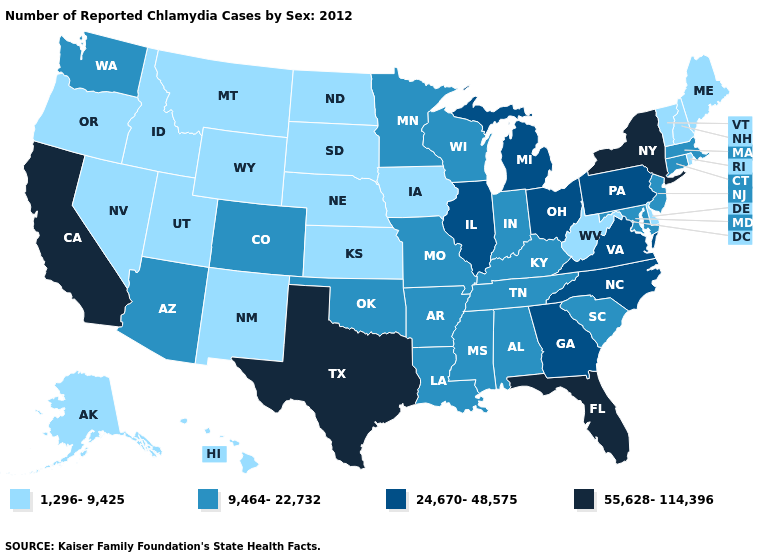Does South Dakota have the lowest value in the USA?
Keep it brief. Yes. Among the states that border Indiana , does Illinois have the highest value?
Concise answer only. Yes. Name the states that have a value in the range 1,296-9,425?
Give a very brief answer. Alaska, Delaware, Hawaii, Idaho, Iowa, Kansas, Maine, Montana, Nebraska, Nevada, New Hampshire, New Mexico, North Dakota, Oregon, Rhode Island, South Dakota, Utah, Vermont, West Virginia, Wyoming. What is the value of Colorado?
Concise answer only. 9,464-22,732. What is the value of Connecticut?
Short answer required. 9,464-22,732. Name the states that have a value in the range 9,464-22,732?
Keep it brief. Alabama, Arizona, Arkansas, Colorado, Connecticut, Indiana, Kentucky, Louisiana, Maryland, Massachusetts, Minnesota, Mississippi, Missouri, New Jersey, Oklahoma, South Carolina, Tennessee, Washington, Wisconsin. What is the value of Wisconsin?
Concise answer only. 9,464-22,732. What is the value of Virginia?
Short answer required. 24,670-48,575. Name the states that have a value in the range 9,464-22,732?
Be succinct. Alabama, Arizona, Arkansas, Colorado, Connecticut, Indiana, Kentucky, Louisiana, Maryland, Massachusetts, Minnesota, Mississippi, Missouri, New Jersey, Oklahoma, South Carolina, Tennessee, Washington, Wisconsin. Is the legend a continuous bar?
Quick response, please. No. What is the value of Missouri?
Be succinct. 9,464-22,732. What is the value of Tennessee?
Answer briefly. 9,464-22,732. Name the states that have a value in the range 55,628-114,396?
Quick response, please. California, Florida, New York, Texas. Does Tennessee have the lowest value in the USA?
Be succinct. No. What is the highest value in the Northeast ?
Write a very short answer. 55,628-114,396. 